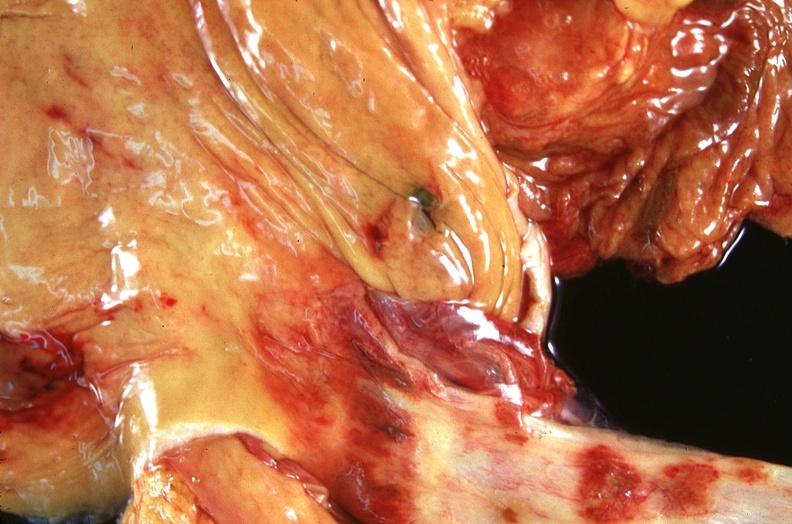s gastrointestinal present?
Answer the question using a single word or phrase. Yes 